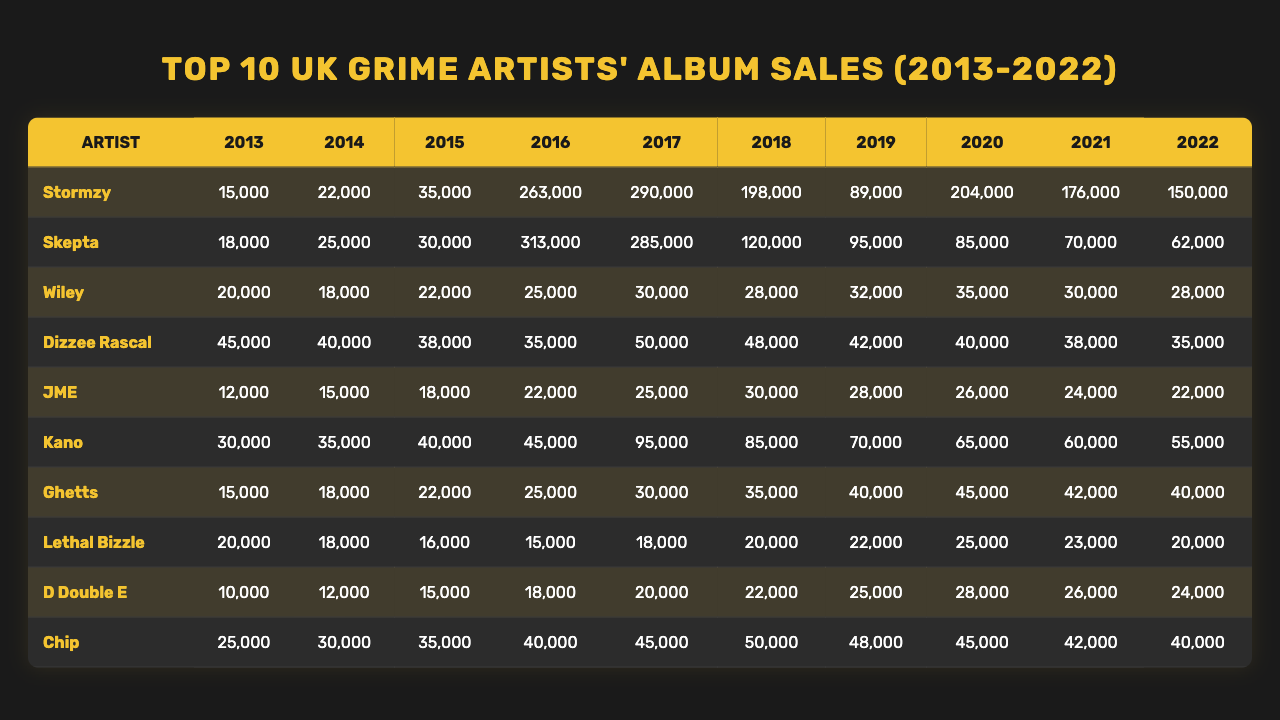What was the total album sales for Stormzy from 2013 to 2022? To find the total sales, sum the values for Stormzy across all years: 15000 + 22000 + 35000 + 263000 + 290000 + 198000 + 89000 + 204000 + 176000 + 150000 = 1,510,000.
Answer: 1,510,000 Which artist had the highest single-year album sales, and in which year? Looking through each artist's sales for each year, Stormzy had the highest single-year sales in 2016 with 263,000.
Answer: Stormzy in 2016 What is the average annual sales for JME over the decade? To find the average, sum JME's sales: 12000 + 15000 + 18000 + 22000 + 25000 + 30000 + 28000 + 26000 + 24000 + 22000 = 2,26000, then divide by 10: 226000 / 10 = 22600.
Answer: 22,600 Did Chip's album sales increase consistently over the last decade? By checking Chip's sales across the years, they are: 25000, 30000, 35000, 40000, 45000, 50000, 48000, 45000, 42000, 40000. Not all values increase; hence, it is false.
Answer: No What was the total sales for all artists combined in the year 2019? The sales for each artist in 2019 are: Stormzy 89000, Skepta 95000, Wiley 32000, Dizzee Rascal 42000, JME 28000, Kano 70000, Ghetts 40000, Lethal Bizzle 22000, D Double E 25000, Chip 48000. Summing these gives 89000 + 95000 + 32000 + 42000 + 28000 + 70000 + 40000 + 22000 + 25000 + 48000 = 419,000.
Answer: 419,000 Who had the second lowest album sales in 2022? Checking the sales for each artist in the year 2022, they are: Stormzy 150000, Skepta 62000, Wiley 28000, Dizzee Rascal 35000, JME 22000, Kano 55000, Ghetts 40000, Lethal Bizzle 20000, D Double E 24000, Chip 40000. Lethal Bizzle has the second lowest with 20000 after JME (22000).
Answer: Lethal Bizzle What was the percentage increase in sales for Skepta from 2018 to 2019? Skepta's sales in 2018 were 120000 and in 2019 were 95000. The percentage decrease is calculated as (120000 - 95000) / 120000 * 100 = 20.83%.
Answer: 20.83% Which artist had the lowest total album sales throughout the entire decade? Summing the sales for all years for each artist, Wiley's total is lowest at 178,000 compared to others.
Answer: Wiley What is the median album sale for Kano over the decade? Kano's sales in order are: 30000, 35000, 40000, 45000, 95000, 85000, 70000, 65000, 60000, 55000. The median is the average of the 5th and 6th values: (95000 + 85000) / 2 = 90000.
Answer: 90000 Was there any year where all artists sold more than 100,000 albums? Observing the sales data, there were no years where all the artists exceeded 100,000 sales; therefore, it is false.
Answer: No 